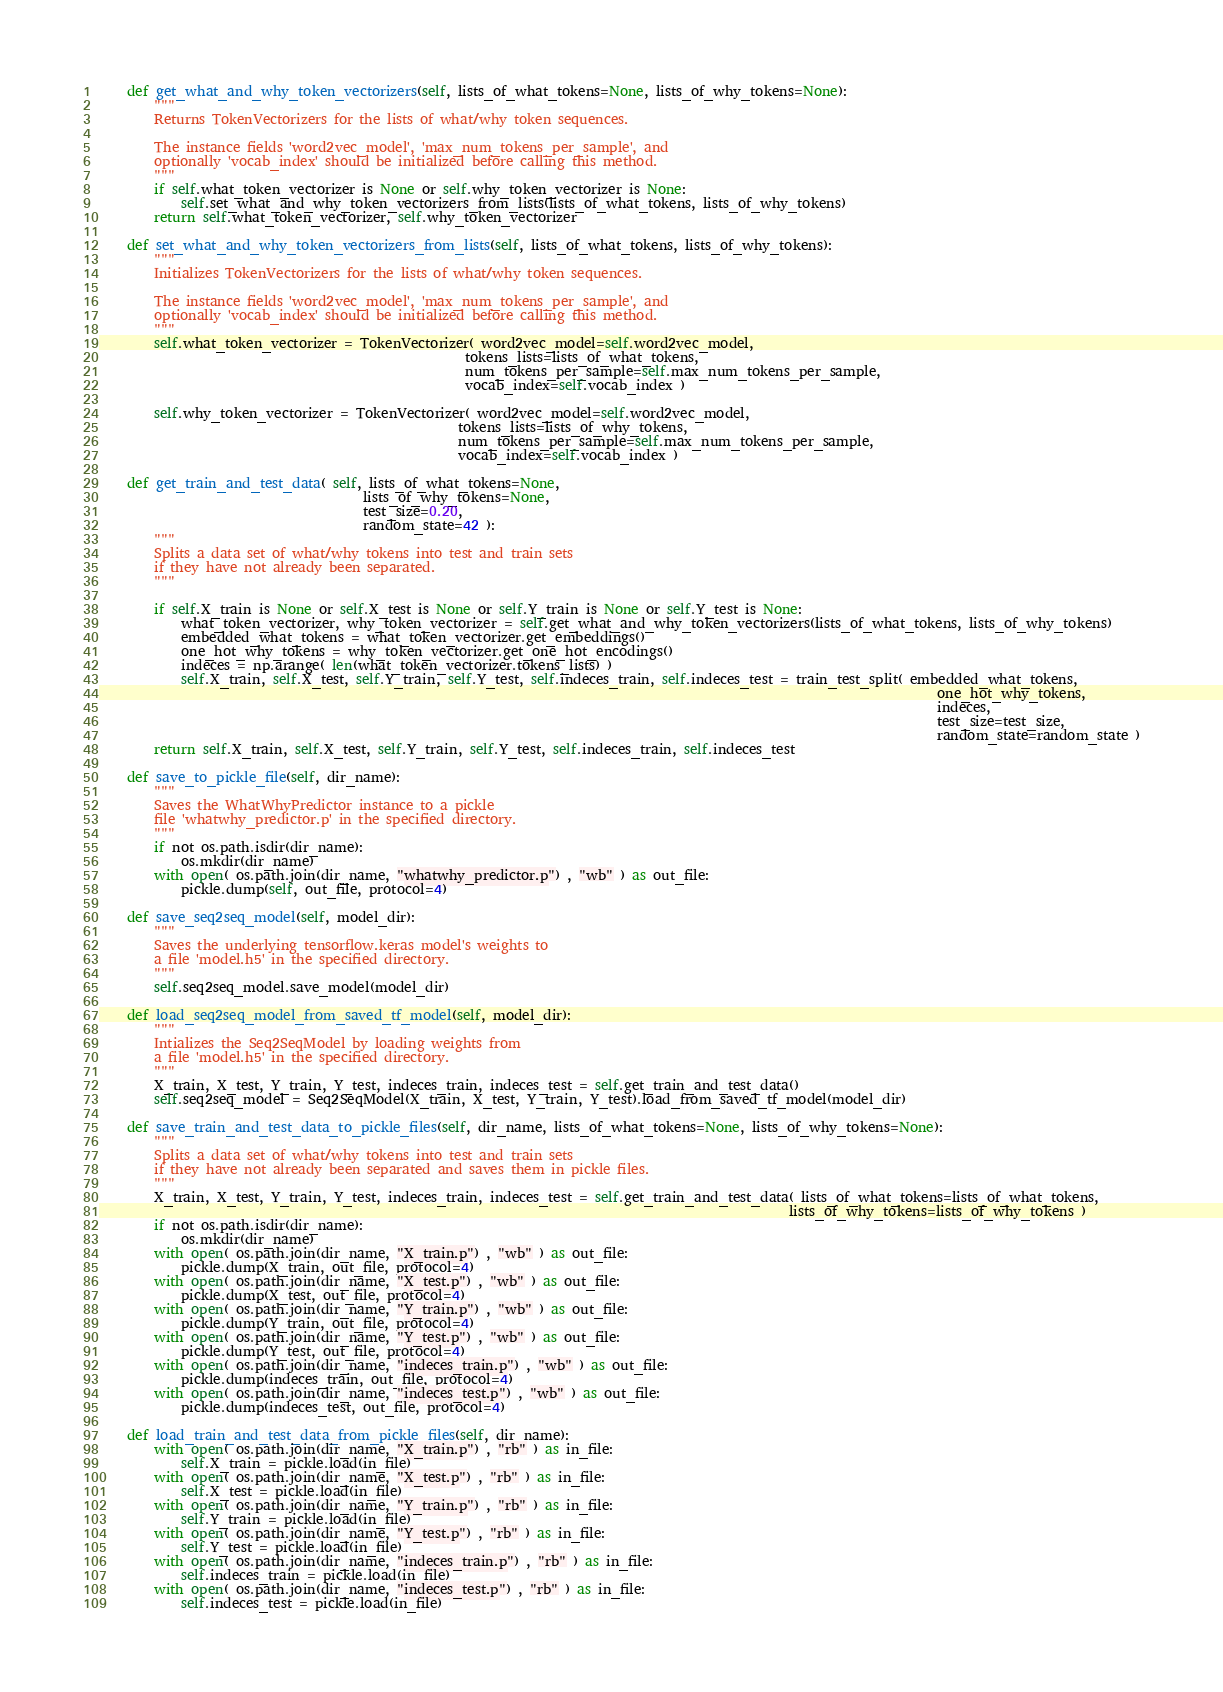<code> <loc_0><loc_0><loc_500><loc_500><_Python_>
    def get_what_and_why_token_vectorizers(self, lists_of_what_tokens=None, lists_of_why_tokens=None):
        """
        Returns TokenVectorizers for the lists of what/why token sequences.
        
        The instance fields 'word2vec_model', 'max_num_tokens_per_sample', and
        optionally 'vocab_index' should be initialized before calling this method.
        """
        if self.what_token_vectorizer is None or self.why_token_vectorizer is None:
            self.set_what_and_why_token_vectorizers_from_lists(lists_of_what_tokens, lists_of_why_tokens)
        return self.what_token_vectorizer, self.why_token_vectorizer

    def set_what_and_why_token_vectorizers_from_lists(self, lists_of_what_tokens, lists_of_why_tokens):
        """
        Initializes TokenVectorizers for the lists of what/why token sequences.
        
        The instance fields 'word2vec_model', 'max_num_tokens_per_sample', and
        optionally 'vocab_index' should be initialized before calling this method.
        """
        self.what_token_vectorizer = TokenVectorizer( word2vec_model=self.word2vec_model,
                                                      tokens_lists=lists_of_what_tokens,
                                                      num_tokens_per_sample=self.max_num_tokens_per_sample,
                                                      vocab_index=self.vocab_index )
        
        self.why_token_vectorizer = TokenVectorizer( word2vec_model=self.word2vec_model,
                                                     tokens_lists=lists_of_why_tokens,
                                                     num_tokens_per_sample=self.max_num_tokens_per_sample,
                                                     vocab_index=self.vocab_index )

    def get_train_and_test_data( self, lists_of_what_tokens=None,
                                       lists_of_why_tokens=None,
                                       test_size=0.20,
                                       random_state=42 ):
        """
        Splits a data set of what/why tokens into test and train sets
        if they have not already been separated.
        """

        if self.X_train is None or self.X_test is None or self.Y_train is None or self.Y_test is None:
            what_token_vectorizer, why_token_vectorizer = self.get_what_and_why_token_vectorizers(lists_of_what_tokens, lists_of_why_tokens)
            embedded_what_tokens = what_token_vectorizer.get_embeddings()
            one_hot_why_tokens = why_token_vectorizer.get_one_hot_encodings()
            indeces = np.arange( len(what_token_vectorizer.tokens_lists) )
            self.X_train, self.X_test, self.Y_train, self.Y_test, self.indeces_train, self.indeces_test = train_test_split( embedded_what_tokens,
                                                                                                                            one_hot_why_tokens,
                                                                                                                            indeces,
                                                                                                                            test_size=test_size,
                                                                                                                            random_state=random_state )
        return self.X_train, self.X_test, self.Y_train, self.Y_test, self.indeces_train, self.indeces_test

    def save_to_pickle_file(self, dir_name):
        """
        Saves the WhatWhyPredictor instance to a pickle
        file 'whatwhy_predictor.p' in the specified directory.
        """
        if not os.path.isdir(dir_name):
            os.mkdir(dir_name)
        with open( os.path.join(dir_name, "whatwhy_predictor.p") , "wb" ) as out_file:
            pickle.dump(self, out_file, protocol=4)

    def save_seq2seq_model(self, model_dir):
        """
        Saves the underlying tensorflow.keras model's weights to
        a file 'model.h5' in the specified directory.
        """
        self.seq2seq_model.save_model(model_dir)

    def load_seq2seq_model_from_saved_tf_model(self, model_dir):
        """
        Intializes the Seq2SeqModel by loading weights from
        a file 'model.h5' in the specified directory.
        """
        X_train, X_test, Y_train, Y_test, indeces_train, indeces_test = self.get_train_and_test_data()
        self.seq2seq_model = Seq2SeqModel(X_train, X_test, Y_train, Y_test).load_from_saved_tf_model(model_dir)

    def save_train_and_test_data_to_pickle_files(self, dir_name, lists_of_what_tokens=None, lists_of_why_tokens=None):
        """
        Splits a data set of what/why tokens into test and train sets
        if they have not already been separated and saves them in pickle files.
        """
        X_train, X_test, Y_train, Y_test, indeces_train, indeces_test = self.get_train_and_test_data( lists_of_what_tokens=lists_of_what_tokens,
                                                                                                      lists_of_why_tokens=lists_of_why_tokens )
        if not os.path.isdir(dir_name):
            os.mkdir(dir_name)
        with open( os.path.join(dir_name, "X_train.p") , "wb" ) as out_file:
            pickle.dump(X_train, out_file, protocol=4)
        with open( os.path.join(dir_name, "X_test.p") , "wb" ) as out_file:
            pickle.dump(X_test, out_file, protocol=4)
        with open( os.path.join(dir_name, "Y_train.p") , "wb" ) as out_file:
            pickle.dump(Y_train, out_file, protocol=4)
        with open( os.path.join(dir_name, "Y_test.p") , "wb" ) as out_file:
            pickle.dump(Y_test, out_file, protocol=4)
        with open( os.path.join(dir_name, "indeces_train.p") , "wb" ) as out_file:
            pickle.dump(indeces_train, out_file, protocol=4)
        with open( os.path.join(dir_name, "indeces_test.p") , "wb" ) as out_file:
            pickle.dump(indeces_test, out_file, protocol=4)

    def load_train_and_test_data_from_pickle_files(self, dir_name):
        with open( os.path.join(dir_name, "X_train.p") , "rb" ) as in_file:
            self.X_train = pickle.load(in_file)
        with open( os.path.join(dir_name, "X_test.p") , "rb" ) as in_file:
            self.X_test = pickle.load(in_file)
        with open( os.path.join(dir_name, "Y_train.p") , "rb" ) as in_file:
            self.Y_train = pickle.load(in_file)
        with open( os.path.join(dir_name, "Y_test.p") , "rb" ) as in_file:
            self.Y_test = pickle.load(in_file)
        with open( os.path.join(dir_name, "indeces_train.p") , "rb" ) as in_file:
            self.indeces_train = pickle.load(in_file)
        with open( os.path.join(dir_name, "indeces_test.p") , "rb" ) as in_file:
            self.indeces_test = pickle.load(in_file)
</code> 